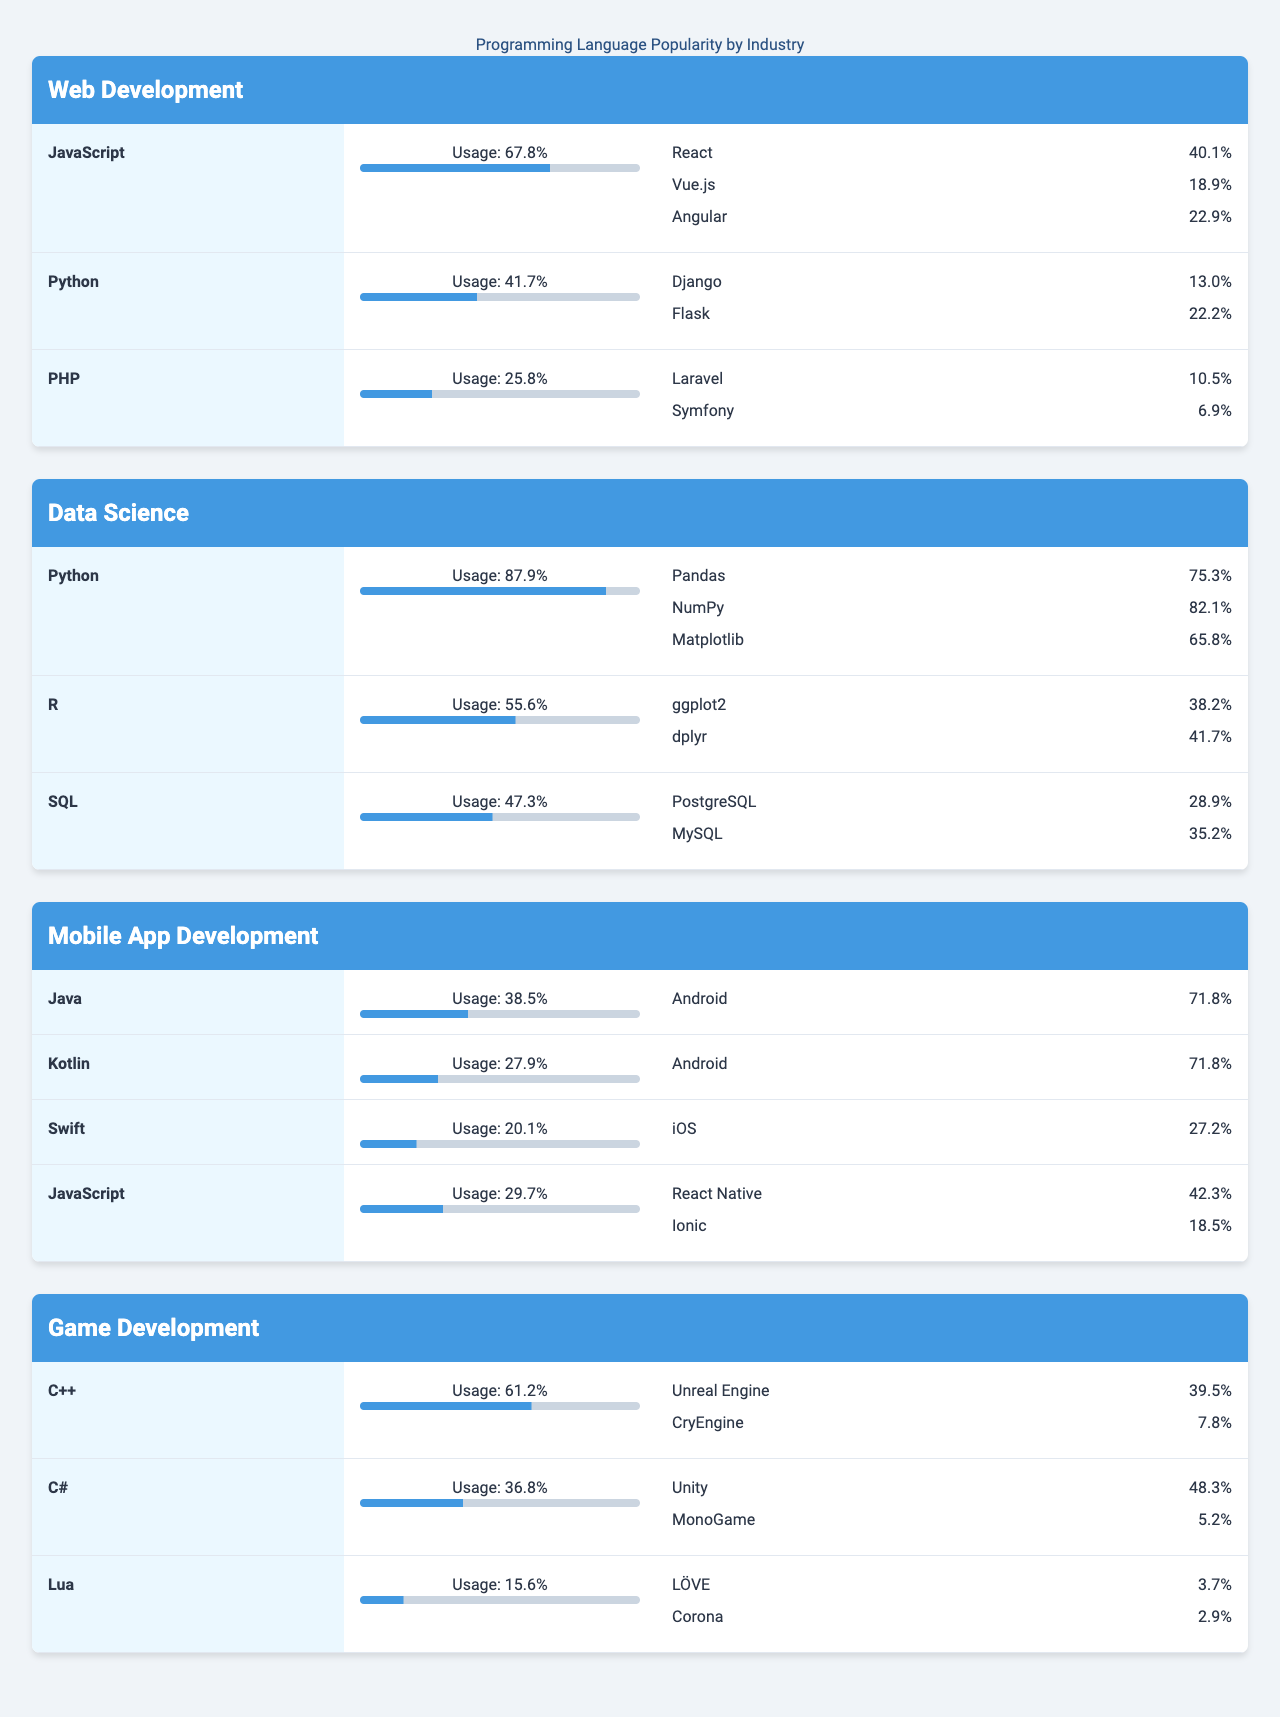what is the most popular programming language in Web Development? By examining the "Web Development" industry section, JavaScript has the highest usage percentage at 67.8%, making it the most popular language in this field.
Answer: JavaScript which programming language is most commonly used in Data Science? In the "Data Science" section, Python has the highest usage percentage at 87.9%, indicating it is the most commonly used language in this industry.
Answer: Python how many frameworks are associated with PHP? In the "Web Development" section, PHP has two frameworks listed: Laravel and Symfony, making the total count of frameworks associated with PHP equal to two.
Answer: 2 which programming languages have frameworks in Mobile App Development? In the "Mobile App Development" section, JavaScript is the only language listed with frameworks, specifically React Native and Ionic.
Answer: JavaScript what is the average usage of programming languages in Game Development? The usage percentages for the programming languages in Game Development are C++ (61.2%), C# (36.8%), and Lua (15.6%). The average usage is calculated by (61.2 + 36.8 + 15.6) / 3 = 37.73%.
Answer: 37.73% is PHP more popular than Python in Web Development? PHP has a usage percentage of 25.8% in Web Development, which is less than the usage of Python at 41.7%. Therefore, it can be concluded that PHP is not more popular than Python in this industry.
Answer: No which language in Data Science has the highest popularity for its associated libraries? In the "Data Science" section, Python leads with library usage statistics: Pandas (75.3%), NumPy (82.1%), and Matplotlib (65.8%). The maximum popularity among these libraries is 82.1% for NumPy, making it the highest.
Answer: NumPy what is the combined usage percentage of Java and Kotlin in Mobile App Development? Java has a usage of 38.5% and Kotlin has a usage of 27.9% in Mobile App Development. The combined usage percentage is calculated as 38.5 + 27.9 = 66.4%.
Answer: 66.4% how does the usage of R compare to SQL in Data Science? R has a usage percentage of 55.6%, while SQL has a usage of 47.3%. Since R's usage is greater than SQL's usage, it can be inferred that R is more widely used than SQL in Data Science.
Answer: R is more widely used which engine is most popular for C# in Game Development? Review the "Game Development" section for C#, where the associated engines are Unity (48.3%) and MonoGame (5.2%). Unity has the highest popularity at 48.3%, making it the most popular engine for C#.
Answer: Unity 